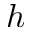<formula> <loc_0><loc_0><loc_500><loc_500>h</formula> 